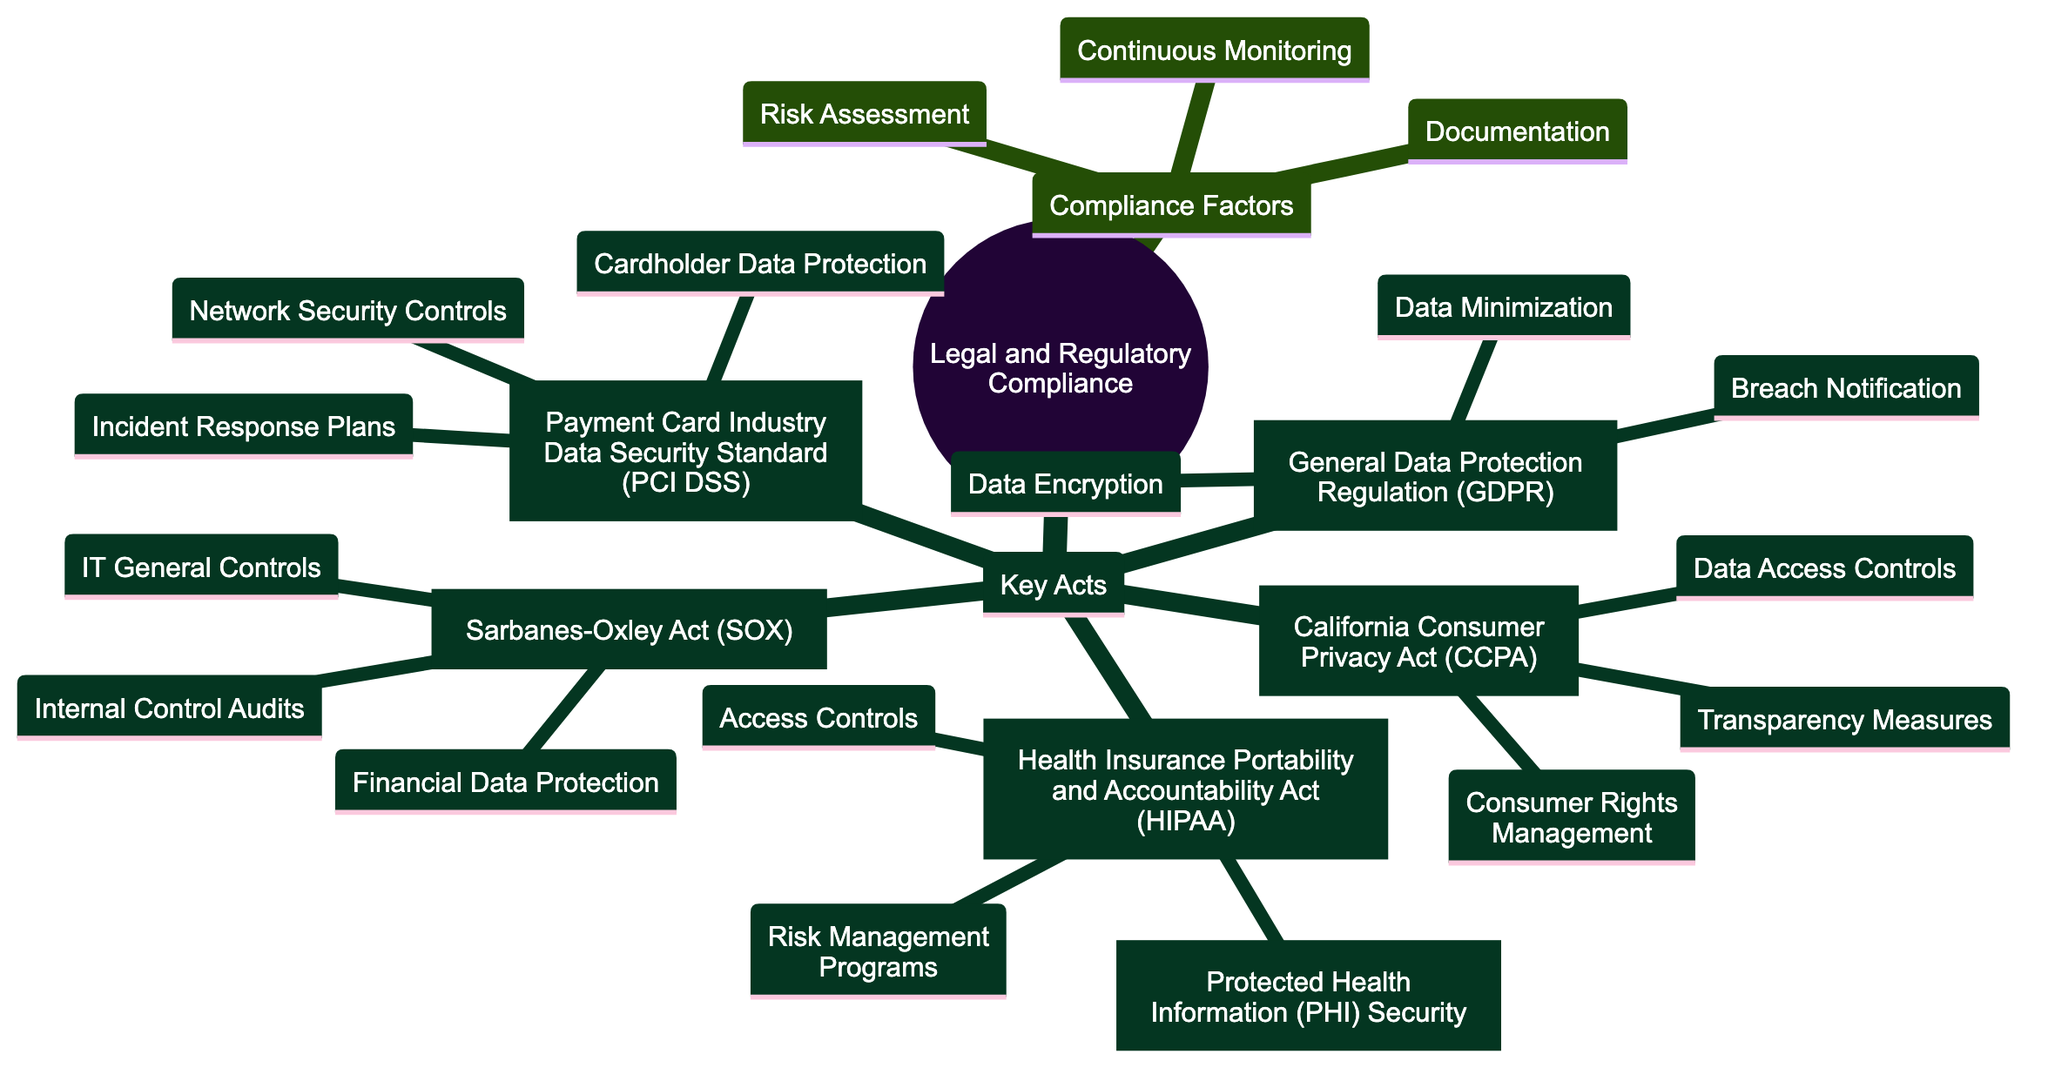What are the compliance factors listed in the diagram? The diagram lists three compliance factors: Risk Assessment, Documentation, and Continuous Monitoring. These factors are directly mentioned under the Compliance Factors node in the diagram.
Answer: Risk Assessment, Documentation, Continuous Monitoring How many key acts are displayed in the diagram? There are a total of five key acts shown in the diagram: GDPR, CCPA, SOX, HIPAA, and PCI DSS. Counting each act provides the total number.
Answer: 5 What is one impact of the General Data Protection Regulation (GDPR) on security posture? The diagram outlines three impacts of GDPR, with one being Data Encryption. This is explicitly noted under the GDPR node.
Answer: Data Encryption Which act emphasizes access controls as part of its impact on security posture? The Health Insurance Portability and Accountability Act (HIPAA) explicitly mentions Access Controls among its impacts on security posture, indicating a focus on managing who can access sensitive data.
Answer: HIPAA What is the relationship between CCPA and transparency measures? The California Consumer Privacy Act (CCPA) includes Transparency Measures as one of its impacts on security posture, indicating that compliance with CCPA encourages practices that enhance transparency regarding data handling.
Answer: CCPA includes Transparency Measures What are the consequences of not adhering to the Sarbanes-Oxley Act (SOX) in terms of security posture? While the diagram does not explicitly list consequences, it implies that failing to implement Internal Control Audits, Financial Data Protection, and IT General Controls could lead to regulatory non-compliance and security vulnerabilities.
Answer: Regulatory non-compliance and security vulnerabilities How does the Payment Card Industry Data Security Standard (PCI DSS) relate to incident response plans? The PCI DSS specifies Incident Response Plans as a critical component for maintaining security posture when handling cardholder data, reflecting the regulatory necessity of preparedness for data breaches.
Answer: Preparedness for data breaches What is one particular aspect highlighted by the compliance factor of documentation? Documentation is a compliance factor that involves maintaining proper records, procedures, and policies to comply with various regulations, which emphasizes its role in demonstrating compliance and managing risk.
Answer: Maintaining proper records Which act is associated with protected health information security in the diagram? The Health Insurance Portability and Accountability Act (HIPAA) is the act associated with Protected Health Information (PHI) Security as indicated in the diagram under its impacts on security posture.
Answer: HIPAA 